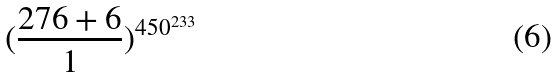Convert formula to latex. <formula><loc_0><loc_0><loc_500><loc_500>( \frac { 2 7 6 + 6 } { 1 } ) ^ { 4 5 0 ^ { 2 3 3 } }</formula> 